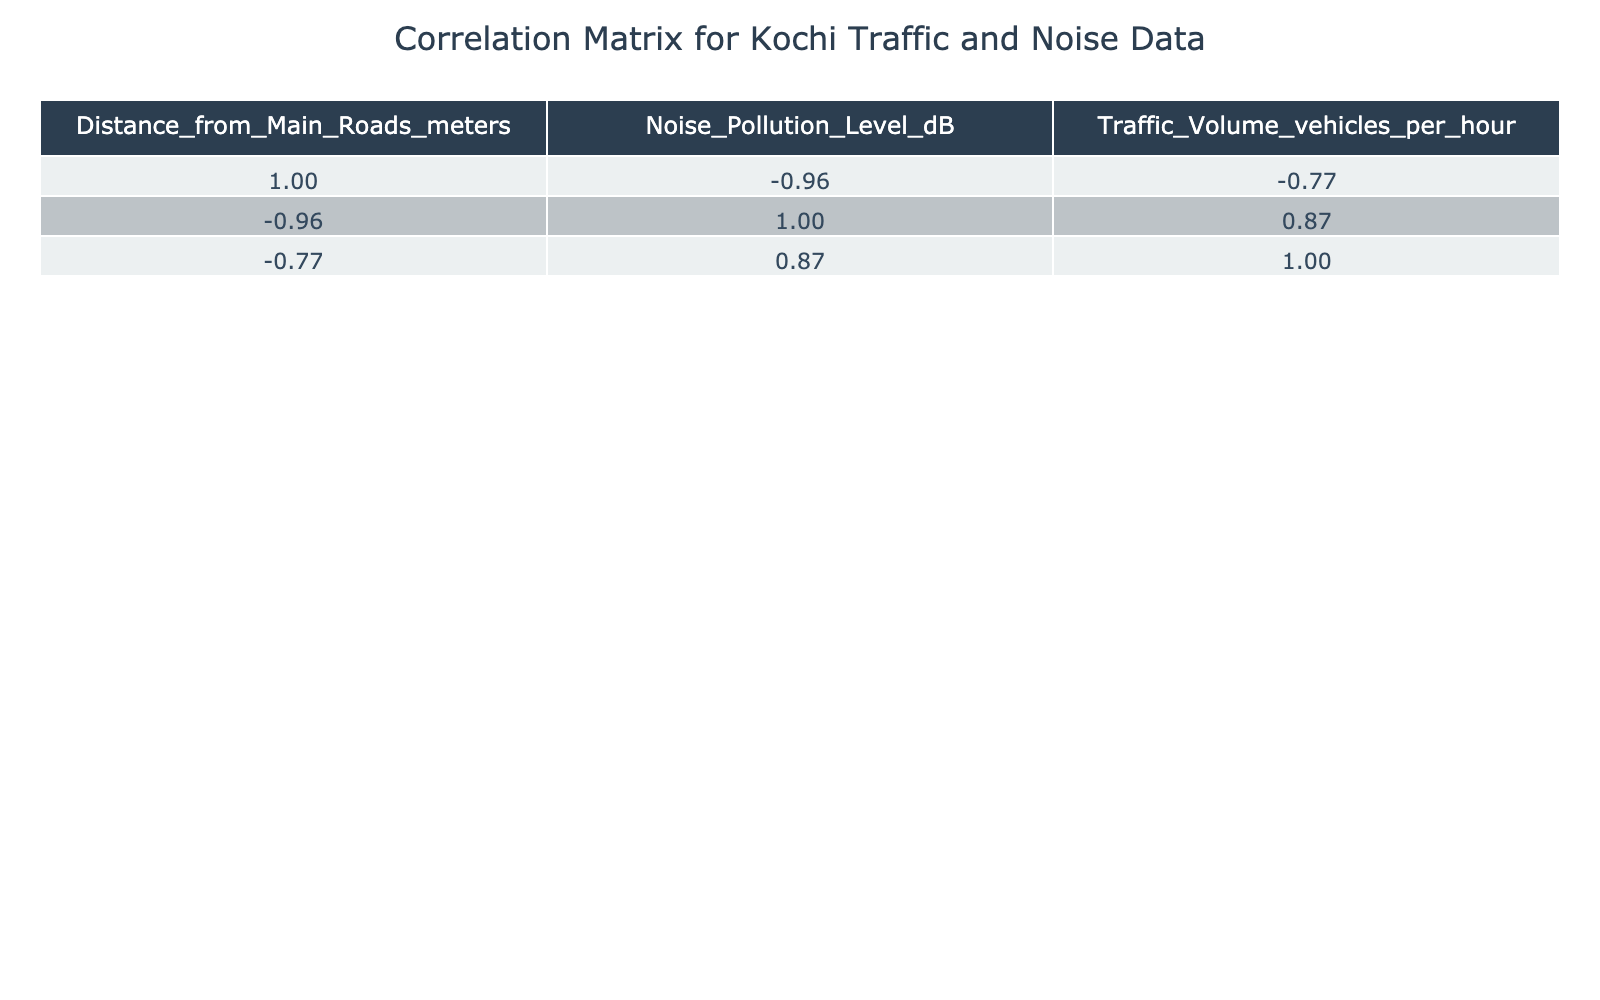What is the noise pollution level at Edappally Flyover? According to the table, the noise pollution level at Edappally Flyover is listed as 90 dB.
Answer: 90 dB What is the distance of Kochi Bus Station from the main roads? The table indicates that the distance from the main roads for Kochi Bus Station is 50 meters.
Answer: 50 meters Is the noise pollution level higher at MG Road compared to Kakkanad Tech Park? MG Road has a noise pollution level of 95 dB, while Kakkanad Tech Park has a noise level of 65 dB. Since 95 dB is greater than 65 dB, the statement is true.
Answer: Yes What is the average distance from the main roads for all locations provided? To find the average distance, we add the distances: (50 + 30 + 20 + 100 + 70 + 150 + 250 + 120 + 80 + 90) = 2100 meters. There are 10 locations, so the average distance is 2100/10 = 210 meters.
Answer: 210 meters Which location has the highest traffic volume? By examining the Traffic Volume column, MG Road has the highest value at 1500 vehicles per hour, compared to other locations.
Answer: MG Road Is there a negative correlation between the distance from main roads and the noise pollution level? To determine this, we check the correlation coefficient between these two metrics in the table. A correlation value close to -1 would indicate a strong negative correlation. If the correlation coefficient is negative and significant, then the answer is yes.
Answer: Yes (if correlation is negative) What is the difference in noise pollution level between Palarivattom and Vyttila Junction? The noise pollution level for Palarivattom is 75 dB and for Vyttila Junction it is 80 dB. To find the difference, subtract 75 from 80: 80 - 75 = 5 dB.
Answer: 5 dB Do all locations with distances greater than 100 meters have noise pollution levels below 80 dB? Checking locations over 100 meters, we see Kakkanad Tech Park at 150 meters has a noise level of 65 dB and Fort Kochi at 250 meters has 55 dB. Therefore, the statement holds true.
Answer: Yes What is the traffic volume for the location with the lowest noise pollution level? The lowest noise pollution level is at Fort Kochi with 55 dB. Referring to the table, the traffic volume for Fort Kochi is 150 vehicles per hour.
Answer: 150 vehicles per hour 